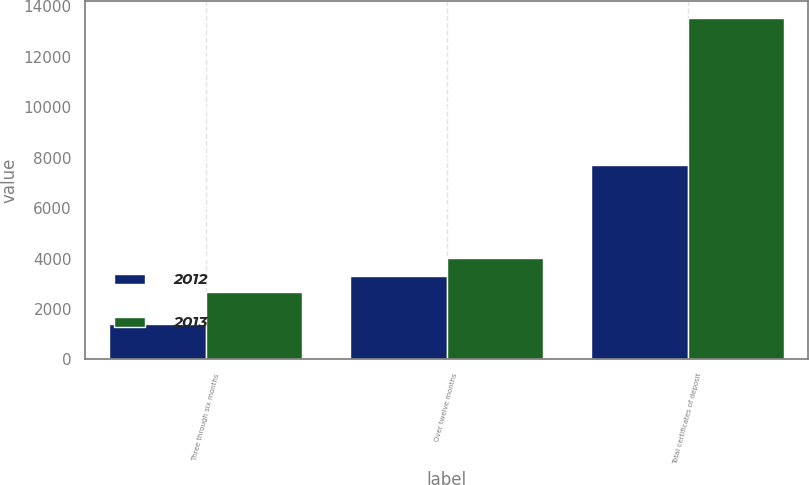Convert chart. <chart><loc_0><loc_0><loc_500><loc_500><stacked_bar_chart><ecel><fcel>Three through six months<fcel>Over twelve months<fcel>Total certificates of deposit<nl><fcel>2012<fcel>1384<fcel>3294<fcel>7702<nl><fcel>2013<fcel>2666<fcel>4019<fcel>13518<nl></chart> 